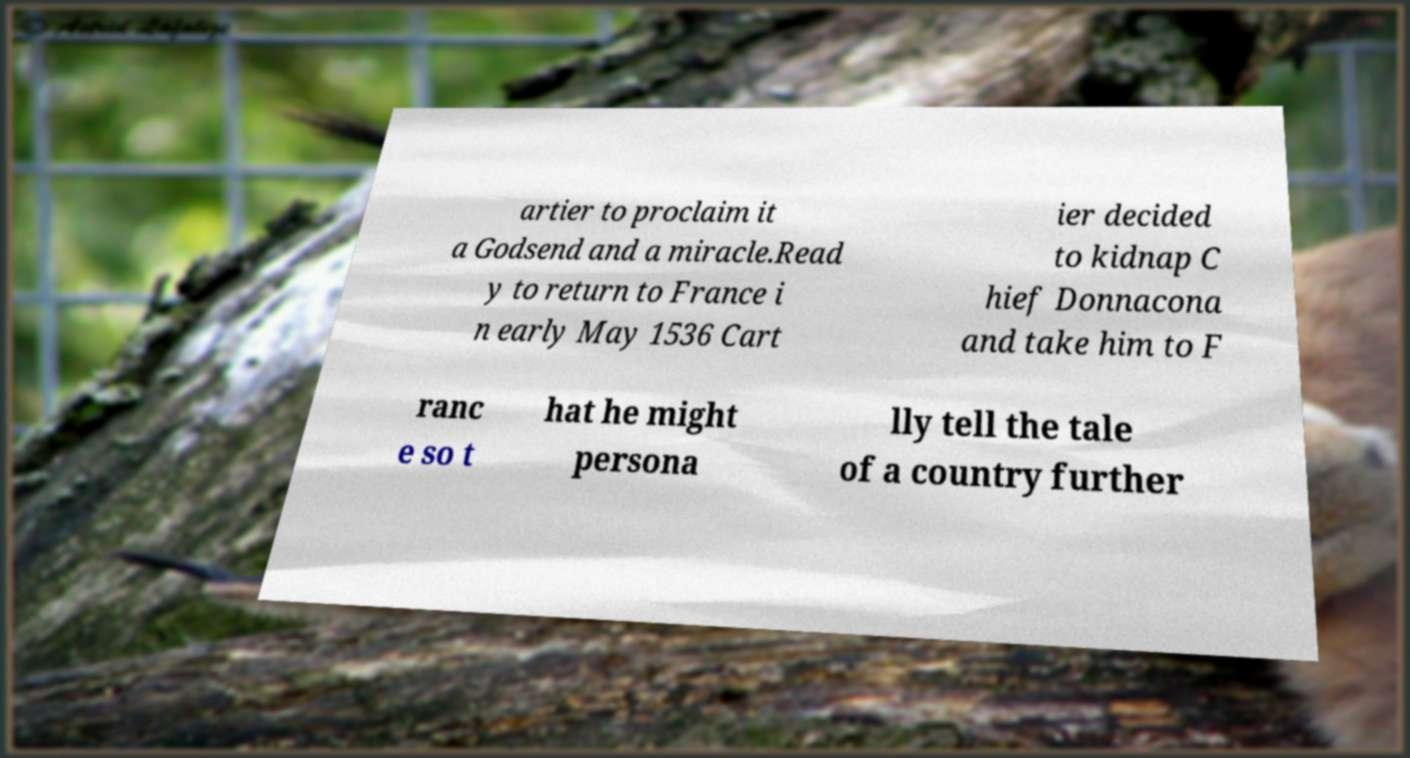Please read and relay the text visible in this image. What does it say? artier to proclaim it a Godsend and a miracle.Read y to return to France i n early May 1536 Cart ier decided to kidnap C hief Donnacona and take him to F ranc e so t hat he might persona lly tell the tale of a country further 